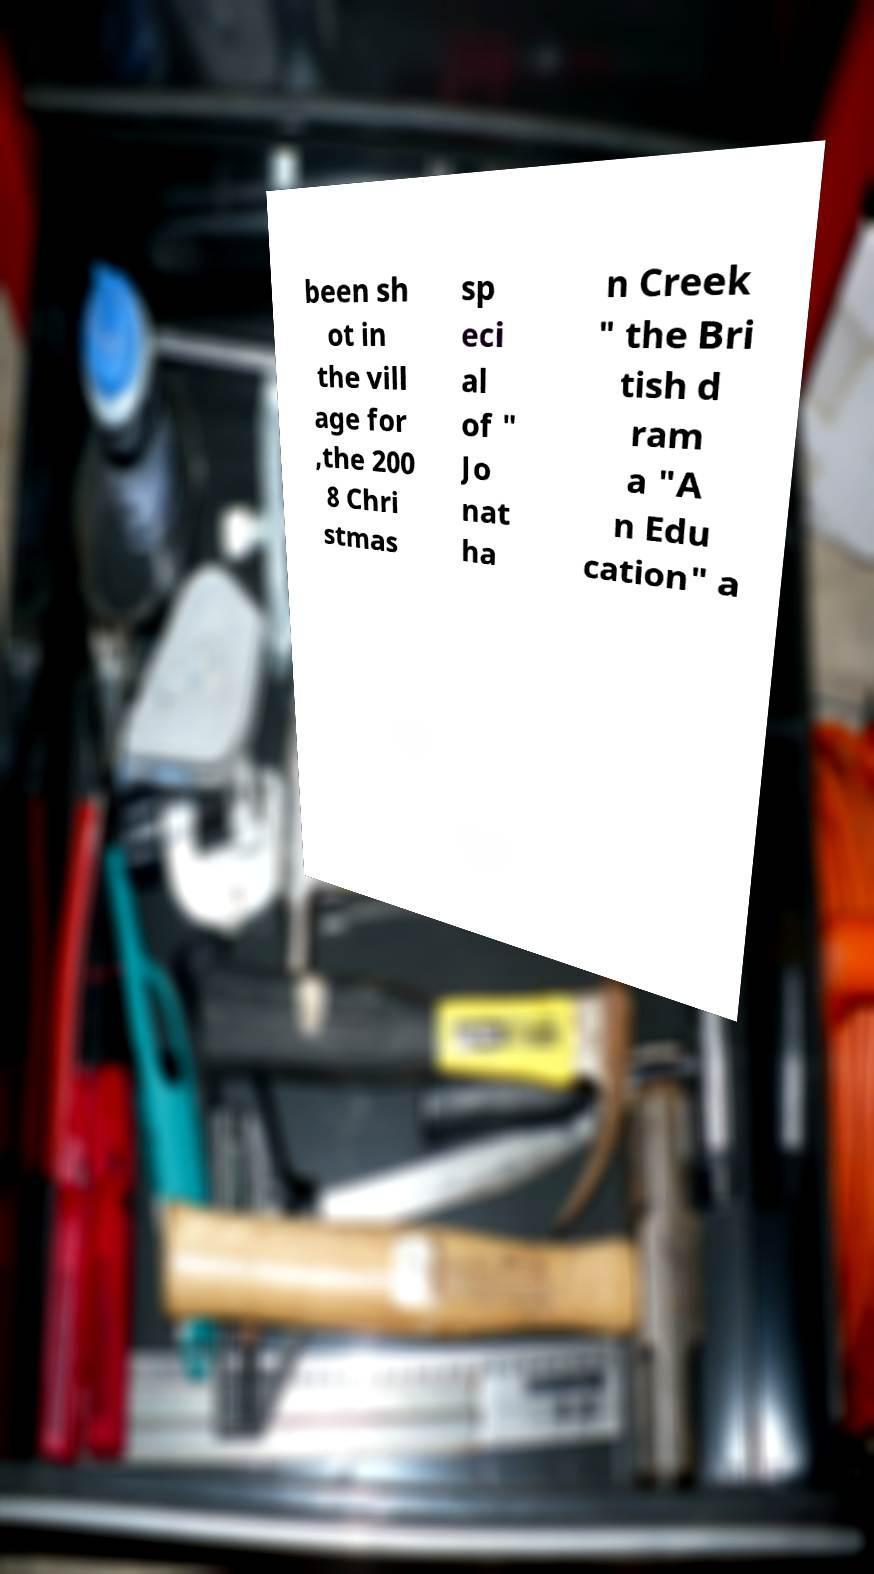For documentation purposes, I need the text within this image transcribed. Could you provide that? been sh ot in the vill age for ,the 200 8 Chri stmas sp eci al of " Jo nat ha n Creek " the Bri tish d ram a "A n Edu cation" a 